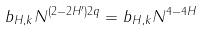<formula> <loc_0><loc_0><loc_500><loc_500>b _ { H , k } N ^ { ( 2 - 2 H ^ { \prime } ) 2 q } = b _ { H , k } N ^ { 4 - 4 H }</formula> 